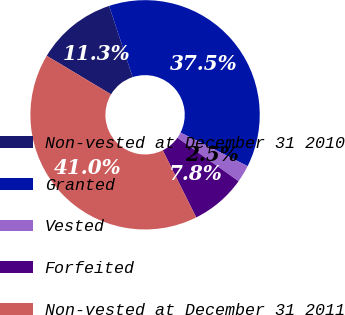Convert chart to OTSL. <chart><loc_0><loc_0><loc_500><loc_500><pie_chart><fcel>Non-vested at December 31 2010<fcel>Granted<fcel>Vested<fcel>Forfeited<fcel>Non-vested at December 31 2011<nl><fcel>11.32%<fcel>37.46%<fcel>2.45%<fcel>7.81%<fcel>40.96%<nl></chart> 